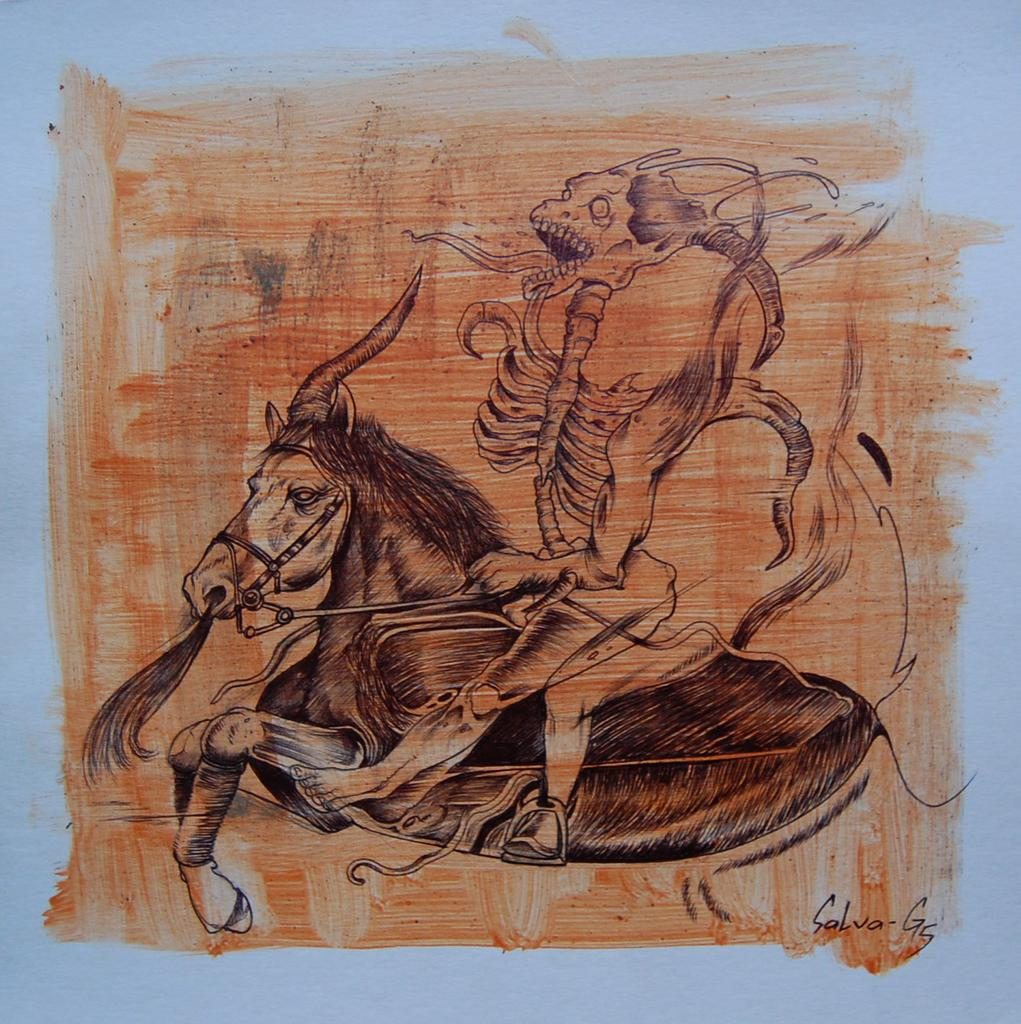What type of artwork is depicted in the image? The image is a painting. What animal is featured in the painting? There is a horse in the painting. What is the horse doing in the painting? The horse is running. What additional element is present on the horse in the painting? There is a skeleton on the horse. Where is the nearest shop to the horse in the painting? There is no shop present in the painting, as it is a painting of a horse running with a skeleton on it. 